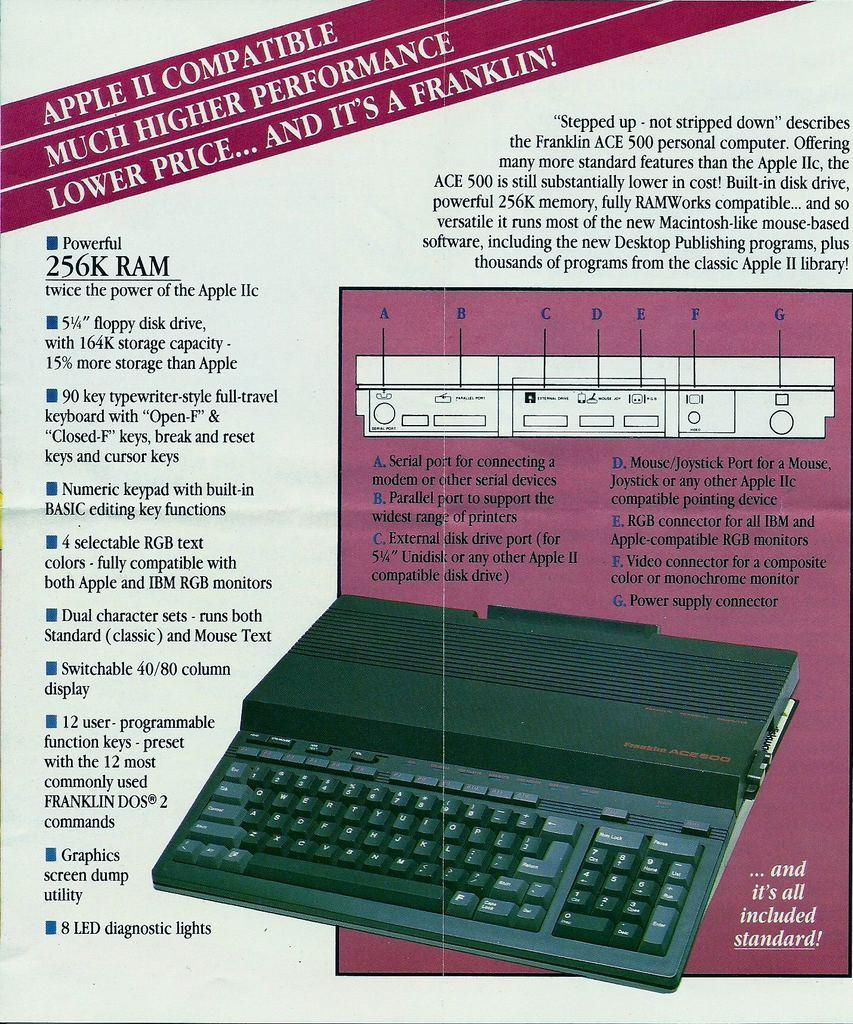<image>
Describe the image concisely. An old Apple II brochure or advertisement showing 256K ram. 